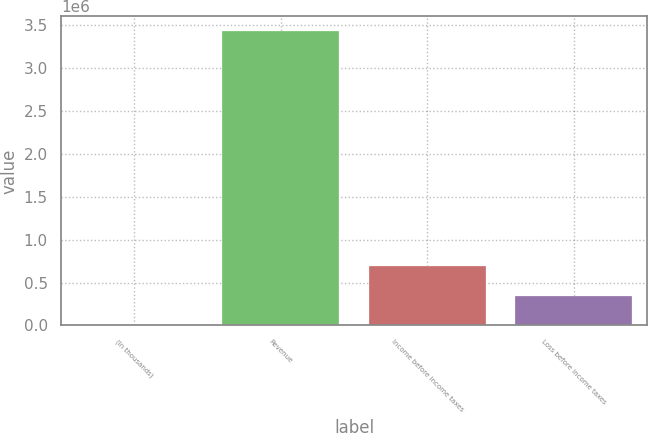Convert chart. <chart><loc_0><loc_0><loc_500><loc_500><bar_chart><fcel>(In thousands)<fcel>Revenue<fcel>Income before income taxes<fcel>Loss before income taxes<nl><fcel>2009<fcel>3.42908e+06<fcel>687422<fcel>344716<nl></chart> 